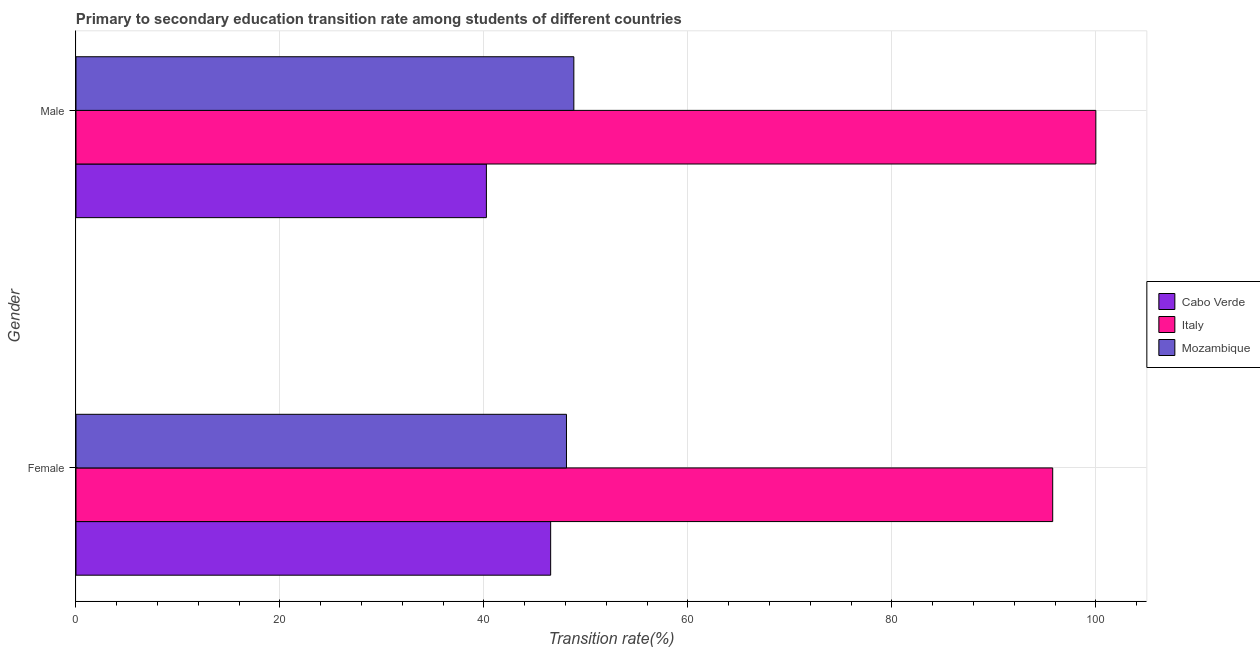How many bars are there on the 1st tick from the bottom?
Offer a terse response. 3. What is the transition rate among female students in Mozambique?
Offer a very short reply. 48.09. Across all countries, what is the maximum transition rate among male students?
Provide a short and direct response. 100. Across all countries, what is the minimum transition rate among male students?
Offer a very short reply. 40.24. In which country was the transition rate among female students maximum?
Ensure brevity in your answer.  Italy. In which country was the transition rate among female students minimum?
Your answer should be very brief. Cabo Verde. What is the total transition rate among male students in the graph?
Ensure brevity in your answer.  189.06. What is the difference between the transition rate among male students in Italy and that in Mozambique?
Make the answer very short. 51.18. What is the difference between the transition rate among male students in Mozambique and the transition rate among female students in Italy?
Provide a succinct answer. -46.95. What is the average transition rate among male students per country?
Provide a succinct answer. 63.02. What is the difference between the transition rate among female students and transition rate among male students in Cabo Verde?
Provide a short and direct response. 6.3. What is the ratio of the transition rate among female students in Mozambique to that in Cabo Verde?
Give a very brief answer. 1.03. In how many countries, is the transition rate among male students greater than the average transition rate among male students taken over all countries?
Offer a terse response. 1. What does the 1st bar from the bottom in Male represents?
Your answer should be compact. Cabo Verde. How many bars are there?
Your answer should be very brief. 6. Are all the bars in the graph horizontal?
Provide a short and direct response. Yes. What is the difference between two consecutive major ticks on the X-axis?
Make the answer very short. 20. Where does the legend appear in the graph?
Your answer should be very brief. Center right. How many legend labels are there?
Offer a very short reply. 3. How are the legend labels stacked?
Make the answer very short. Vertical. What is the title of the graph?
Ensure brevity in your answer.  Primary to secondary education transition rate among students of different countries. Does "Venezuela" appear as one of the legend labels in the graph?
Make the answer very short. No. What is the label or title of the X-axis?
Offer a very short reply. Transition rate(%). What is the Transition rate(%) in Cabo Verde in Female?
Provide a succinct answer. 46.54. What is the Transition rate(%) in Italy in Female?
Provide a short and direct response. 95.77. What is the Transition rate(%) in Mozambique in Female?
Your answer should be very brief. 48.09. What is the Transition rate(%) of Cabo Verde in Male?
Offer a terse response. 40.24. What is the Transition rate(%) of Mozambique in Male?
Give a very brief answer. 48.82. Across all Gender, what is the maximum Transition rate(%) of Cabo Verde?
Offer a very short reply. 46.54. Across all Gender, what is the maximum Transition rate(%) in Italy?
Your response must be concise. 100. Across all Gender, what is the maximum Transition rate(%) in Mozambique?
Keep it short and to the point. 48.82. Across all Gender, what is the minimum Transition rate(%) in Cabo Verde?
Keep it short and to the point. 40.24. Across all Gender, what is the minimum Transition rate(%) of Italy?
Provide a short and direct response. 95.77. Across all Gender, what is the minimum Transition rate(%) of Mozambique?
Your answer should be very brief. 48.09. What is the total Transition rate(%) of Cabo Verde in the graph?
Offer a terse response. 86.78. What is the total Transition rate(%) in Italy in the graph?
Your answer should be compact. 195.77. What is the total Transition rate(%) of Mozambique in the graph?
Give a very brief answer. 96.91. What is the difference between the Transition rate(%) in Cabo Verde in Female and that in Male?
Provide a short and direct response. 6.3. What is the difference between the Transition rate(%) in Italy in Female and that in Male?
Provide a succinct answer. -4.23. What is the difference between the Transition rate(%) of Mozambique in Female and that in Male?
Ensure brevity in your answer.  -0.72. What is the difference between the Transition rate(%) in Cabo Verde in Female and the Transition rate(%) in Italy in Male?
Ensure brevity in your answer.  -53.46. What is the difference between the Transition rate(%) in Cabo Verde in Female and the Transition rate(%) in Mozambique in Male?
Offer a very short reply. -2.27. What is the difference between the Transition rate(%) of Italy in Female and the Transition rate(%) of Mozambique in Male?
Provide a succinct answer. 46.95. What is the average Transition rate(%) of Cabo Verde per Gender?
Provide a succinct answer. 43.39. What is the average Transition rate(%) in Italy per Gender?
Give a very brief answer. 97.89. What is the average Transition rate(%) in Mozambique per Gender?
Your answer should be very brief. 48.45. What is the difference between the Transition rate(%) of Cabo Verde and Transition rate(%) of Italy in Female?
Ensure brevity in your answer.  -49.23. What is the difference between the Transition rate(%) in Cabo Verde and Transition rate(%) in Mozambique in Female?
Provide a short and direct response. -1.55. What is the difference between the Transition rate(%) of Italy and Transition rate(%) of Mozambique in Female?
Provide a short and direct response. 47.68. What is the difference between the Transition rate(%) in Cabo Verde and Transition rate(%) in Italy in Male?
Provide a short and direct response. -59.76. What is the difference between the Transition rate(%) in Cabo Verde and Transition rate(%) in Mozambique in Male?
Provide a short and direct response. -8.58. What is the difference between the Transition rate(%) of Italy and Transition rate(%) of Mozambique in Male?
Give a very brief answer. 51.18. What is the ratio of the Transition rate(%) of Cabo Verde in Female to that in Male?
Your response must be concise. 1.16. What is the ratio of the Transition rate(%) of Italy in Female to that in Male?
Offer a very short reply. 0.96. What is the ratio of the Transition rate(%) of Mozambique in Female to that in Male?
Keep it short and to the point. 0.99. What is the difference between the highest and the second highest Transition rate(%) in Cabo Verde?
Provide a short and direct response. 6.3. What is the difference between the highest and the second highest Transition rate(%) in Italy?
Give a very brief answer. 4.23. What is the difference between the highest and the second highest Transition rate(%) of Mozambique?
Ensure brevity in your answer.  0.72. What is the difference between the highest and the lowest Transition rate(%) in Cabo Verde?
Provide a short and direct response. 6.3. What is the difference between the highest and the lowest Transition rate(%) in Italy?
Make the answer very short. 4.23. What is the difference between the highest and the lowest Transition rate(%) of Mozambique?
Your answer should be compact. 0.72. 